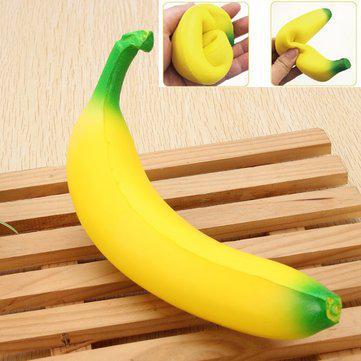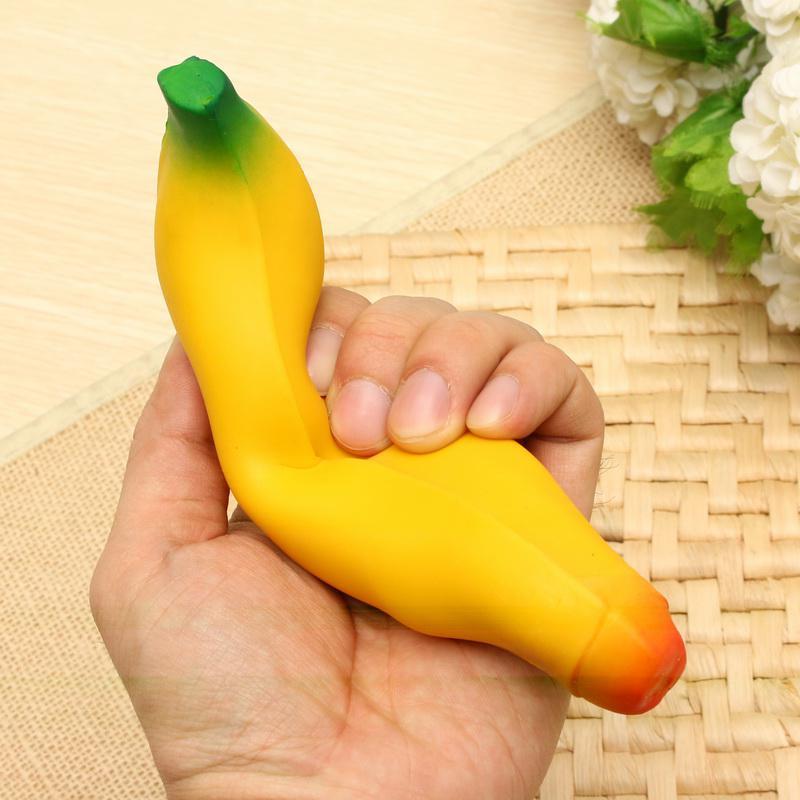The first image is the image on the left, the second image is the image on the right. Assess this claim about the two images: "Someone is placing a banana in a banana slicer in at least one of the pictures.". Correct or not? Answer yes or no. No. The first image is the image on the left, the second image is the image on the right. Considering the images on both sides, is "Only fake bananas shown." valid? Answer yes or no. Yes. 